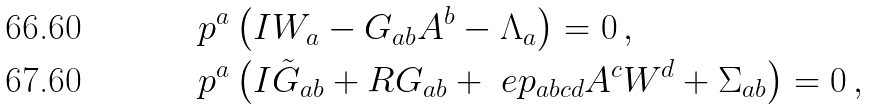<formula> <loc_0><loc_0><loc_500><loc_500>\ p ^ { a } & \left ( I W _ { a } - G _ { a b } A ^ { b } - \Lambda _ { a } \right ) = 0 \, , \\ \ p ^ { a } & \left ( I \tilde { G } _ { a b } + R G _ { a b } + \ e p _ { a b c d } A ^ { c } W ^ { d } + \Sigma _ { a b } \right ) = 0 \, ,</formula> 